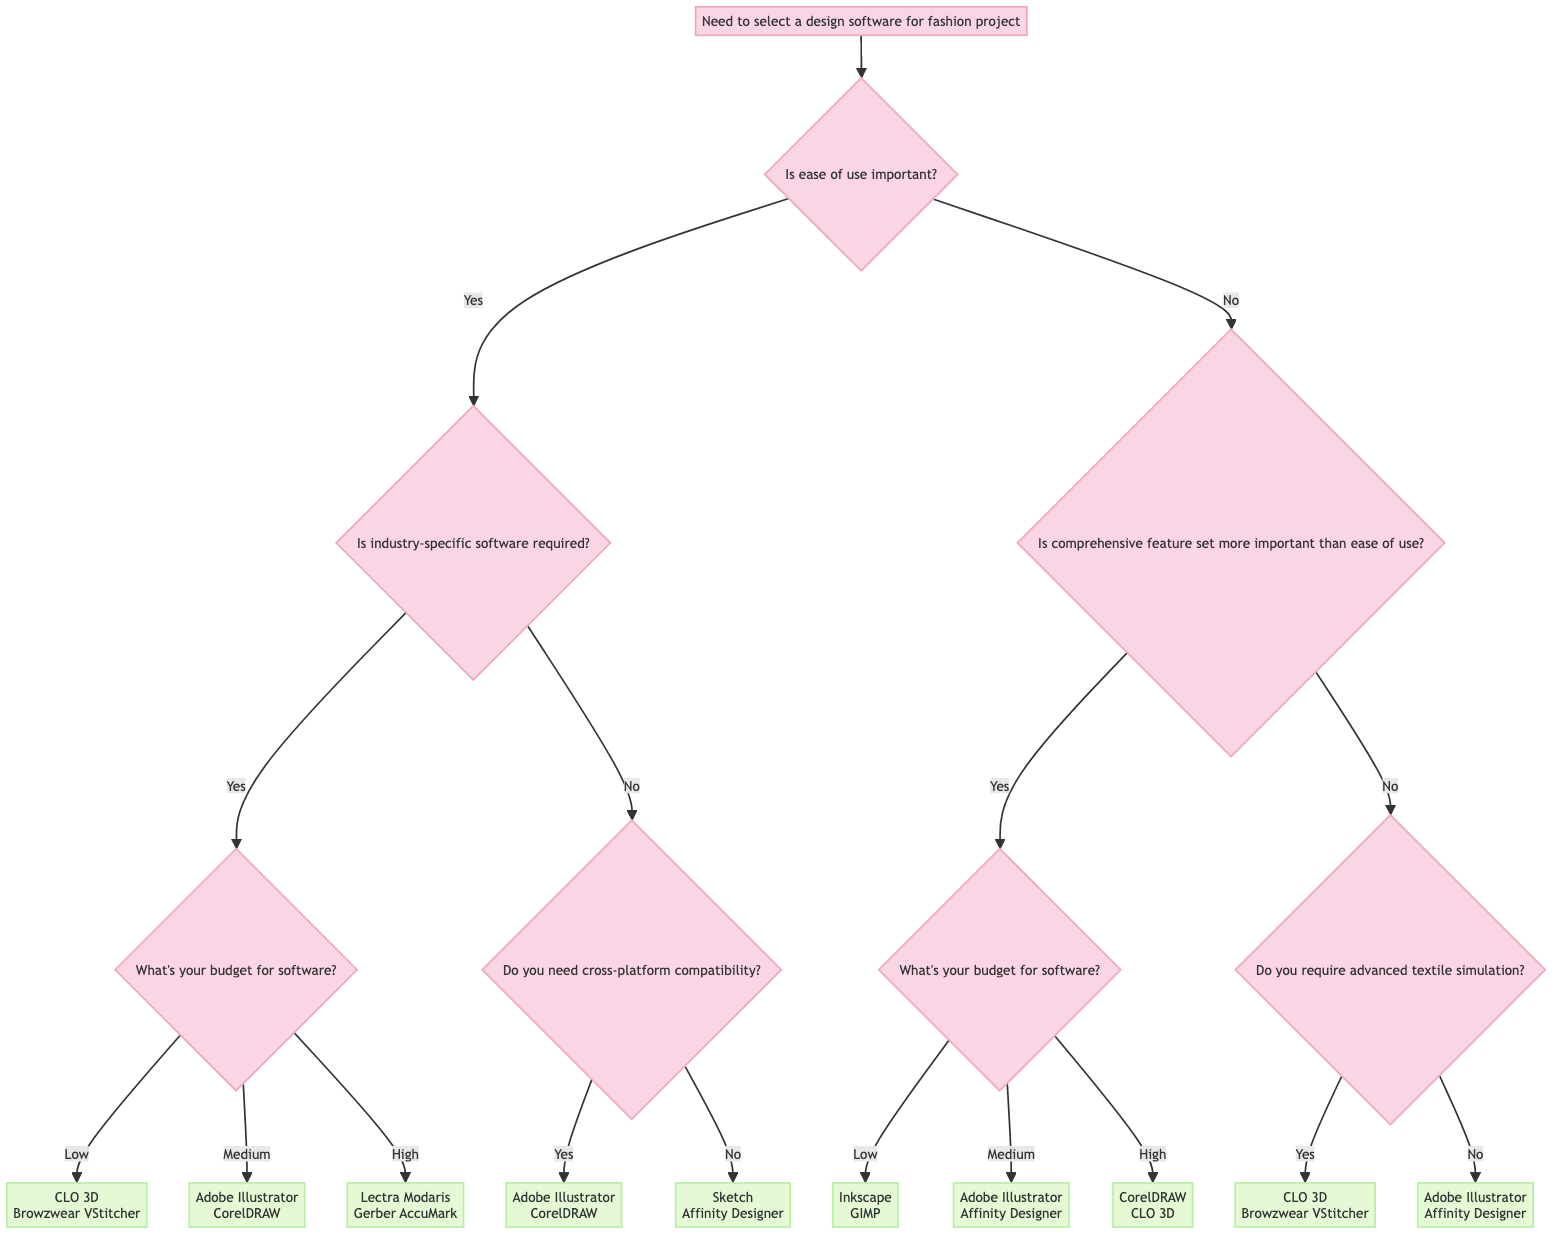What's the first question in the decision tree? The first question in the decision tree is about the importance of ease of use, which is expressed as "Is ease of use important?"
Answer: Is ease of use important? How many options does the second question provide? The second question, "Is industry-specific software required?", has two options: "yes" and "no".
Answer: Two options What design software is suggested for a low budget if industry-specific software is required? If the response to the previous question is "yes" and the budget is "low", the diagram suggests "CLO 3D" and "Browzwear VStitcher".
Answer: CLO 3D, Browzwear VStitcher What happens if comprehensive feature set is prioritized over ease of use? If "no" is selected for ease of use in the first question, and then "yes" is selected for prioritizing comprehensive feature set, the next question is about the budget. Based on the budget, software options are suggested.
Answer: Moves to budget question Do users requiring advanced textile simulation have any software options? Yes, if the user answers "yes" to the requirement for advanced textile simulation, the options provided are "CLO 3D" and "Browzwear VStitcher".
Answer: CLO 3D, Browzwear VStitcher What are the software options if the user does not require cross-platform compatibility? If the user answers "no" to the cross-platform compatibility question, the software options listed are "Sketch" and "Affinity Designer".
Answer: Sketch, Affinity Designer If a user has a high budget and needs a comprehensive feature set, what software options are available? If the user answers "yes" to the need for a comprehensive feature set and indicates a high budget, the recommended software options are "CorelDRAW" and "CLO 3D".
Answer: CorelDRAW, CLO 3D Which question connects the need for industry-specific software and budget considerations? The question that connects these two factors is "What's your budget for software?", and it follows the decision of needing industry-specific software.
Answer: What's your budget for software? 